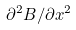<formula> <loc_0><loc_0><loc_500><loc_500>\partial ^ { 2 } B / \partial x ^ { 2 }</formula> 